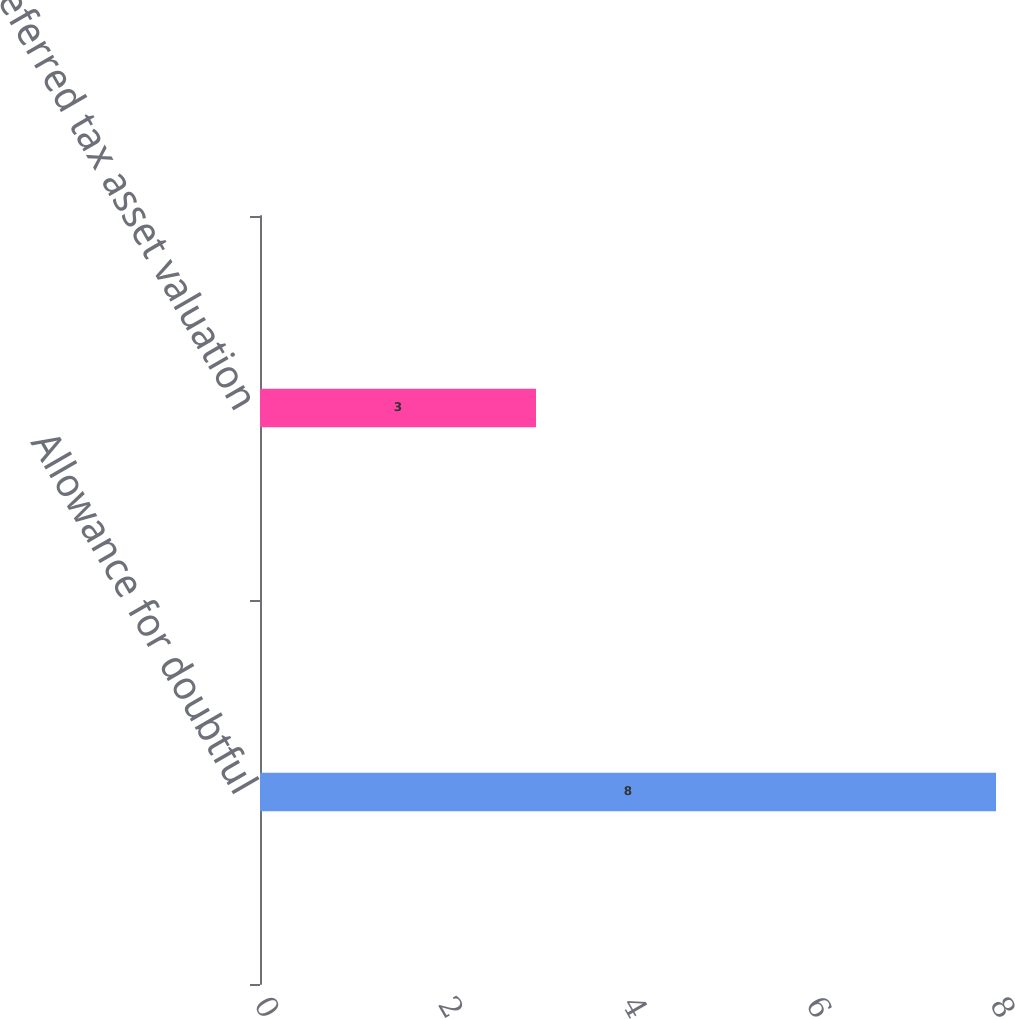Convert chart to OTSL. <chart><loc_0><loc_0><loc_500><loc_500><bar_chart><fcel>Allowance for doubtful<fcel>Deferred tax asset valuation<nl><fcel>8<fcel>3<nl></chart> 